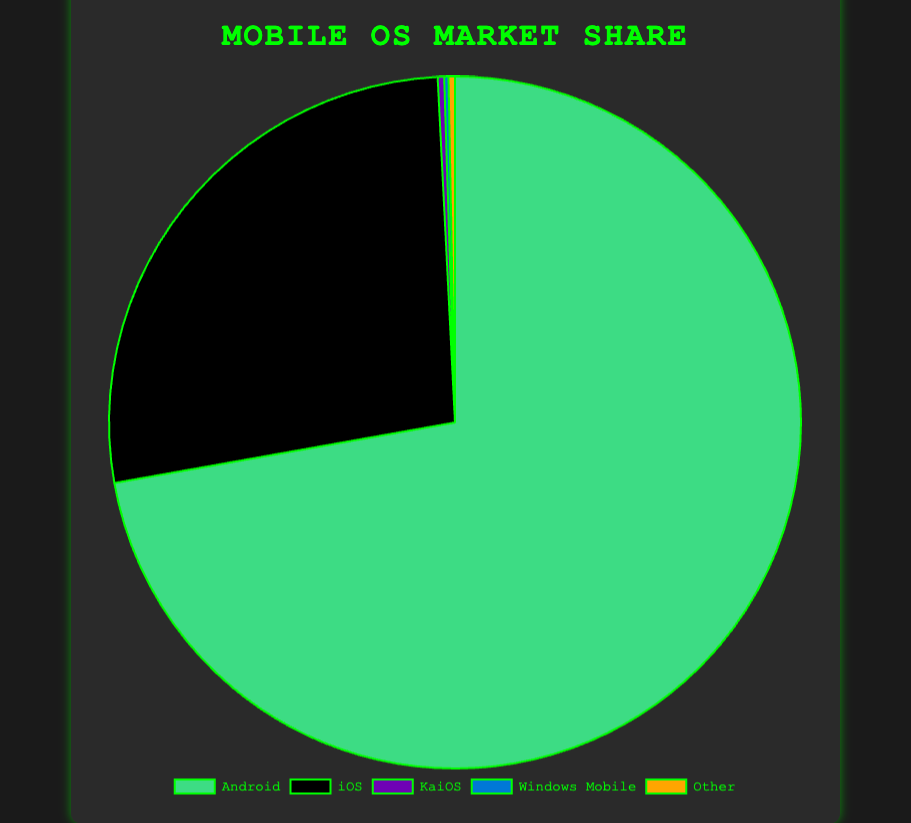What percentage of the market share do Windows Mobile and KaiOS together hold? To find the combined market share of Windows Mobile and KaiOS, add their individual percentages: 0.2% (Windows Mobile) + 0.3% (KaiOS) = 0.5%
Answer: 0.5% Which operating system has the second-largest market share? By comparing the percentages, iOS has the second-largest market share with 27.0%, following Android which has the largest share.
Answer: iOS How much larger is Android's market share compared to iOS? To find the difference between Android and iOS market shares, subtract iOS's percentage from Android's percentage: 72.2% - 27.0% = 45.2%
Answer: 45.2% What is the combined market share of Android and iOS? Add the percentages of Android and iOS: 72.2% + 27.0% = 99.2%
Answer: 99.2% Which operating system has the smallest market share, and what is that percentage? Windows Mobile has the smallest market share with 0.2%. This is found by comparing all market shares: Android (72.2%), iOS (27.0%), KaiOS (0.3%), Windows Mobile (0.2%), Other (0.3%).
Answer: Windows Mobile, 0.2% What is the average market share of all the listed operating systems? Add all the percentages and divide by the number of operating systems: (72.2 + 27.0 + 0.3 + 0.2 + 0.3) / 5 = 100 / 5 = 20%
Answer: 20% Which operating systems have the same market share, and what is that percentage? Both KaiOS and Other have the same market share of 0.3%. This is observed by comparing their percentages in the chart.
Answer: KaiOS and Other, 0.3% What is the visual representation color for Android on the pie chart? Android is represented in green on the pie chart. This is identified by looking at the color scheme of the pie chart segments.
Answer: Green How much more market share does Android have compared to the combined share of KaiOS, Windows Mobile, and Other? First, find the combined share of KaiOS, Windows Mobile, and Other: 0.3 + 0.2 + 0.3 = 0.8%. Then, subtract this from Android's share: 72.2% - 0.8% = 71.4%
Answer: 71.4% 